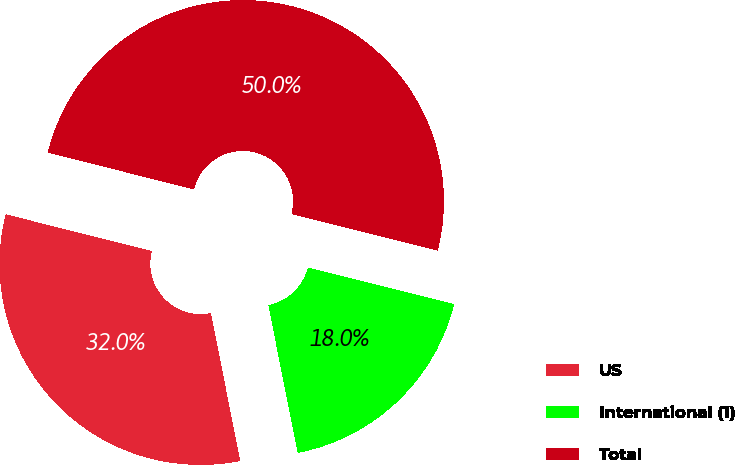Convert chart to OTSL. <chart><loc_0><loc_0><loc_500><loc_500><pie_chart><fcel>US<fcel>International (1)<fcel>Total<nl><fcel>32.04%<fcel>17.96%<fcel>50.0%<nl></chart> 